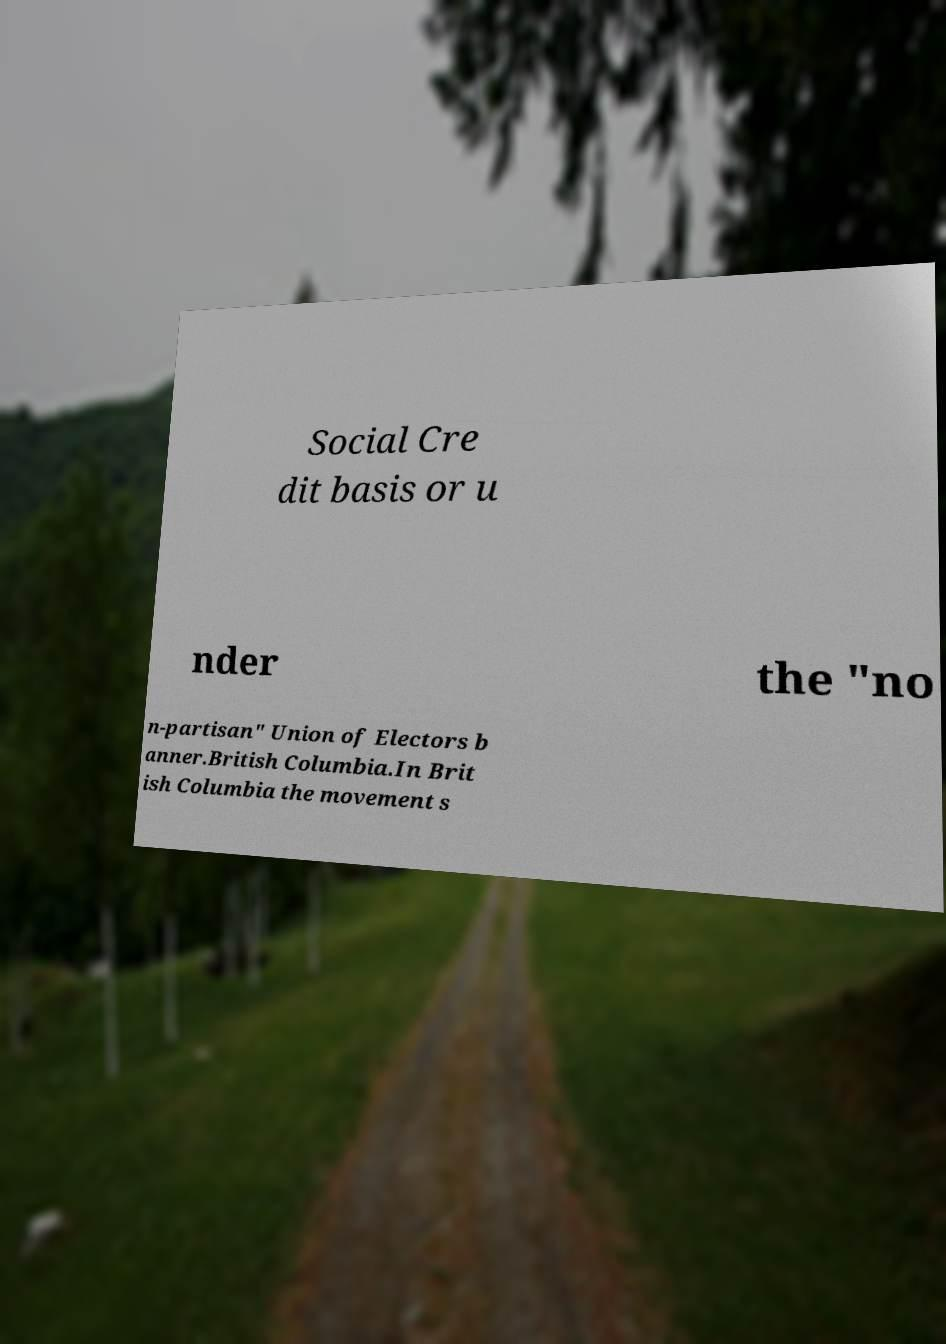Could you assist in decoding the text presented in this image and type it out clearly? Social Cre dit basis or u nder the "no n-partisan" Union of Electors b anner.British Columbia.In Brit ish Columbia the movement s 